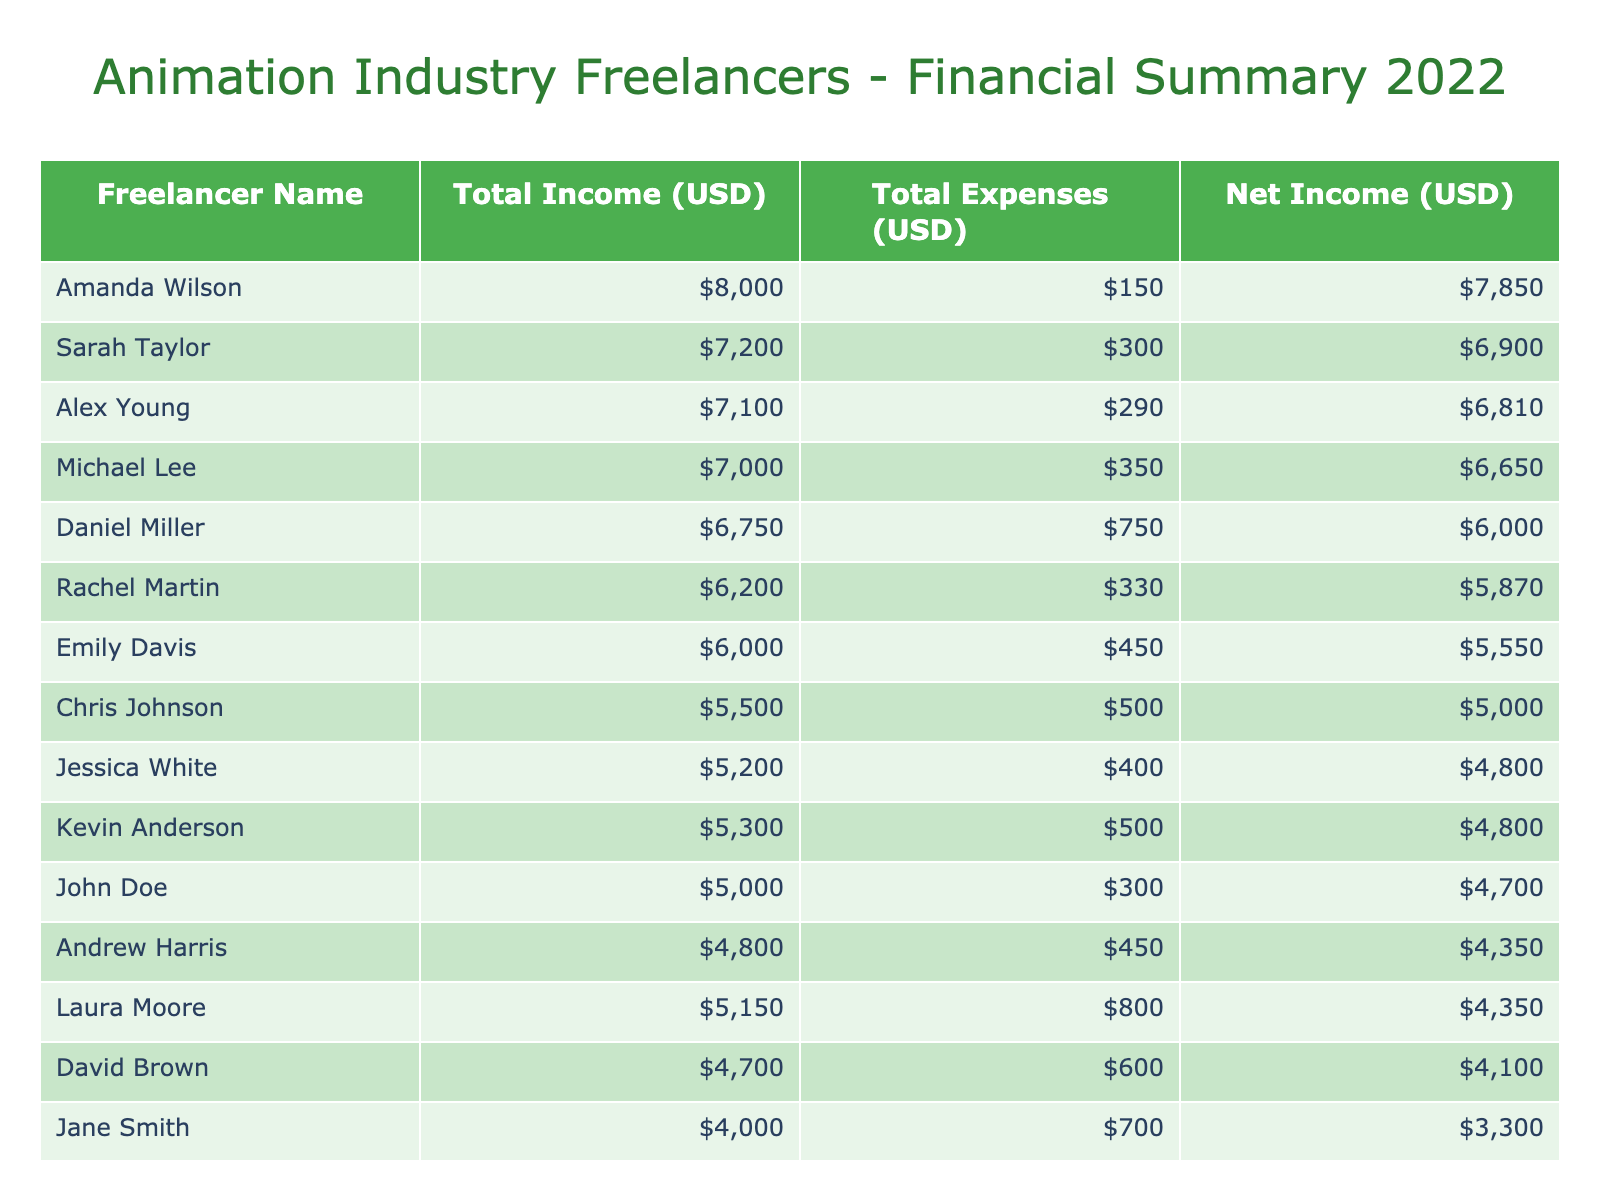What is the total income earned by Amanda Wilson? In the table, we look for the entry with "Amanda Wilson" under the Freelancer Name column. Her income is listed as 8000 USD.
Answer: 8000 USD Who has the highest total expenses among the freelancers? To find this, we compare the "Expense Amount (USD)" for each freelancer in the table. Amanda Wilson has expenses of 150 USD, which is the lowest. The highest expenses are observed for Laura Moore at 800 USD.
Answer: Laura Moore What is the net income for Sarah Taylor? For Sarah Taylor, her total income is 7200 USD, and her total expenses are 300 USD. Net income is calculated by subtracting expenses from income, which is 7200 - 300 = 6900 USD.
Answer: 6900 USD What is the average total income of all freelancers? First, we sum the incomes of each freelancer: 5000 + 4000 + 6000 + 7000 + 5500 + 4700 + 8000 + 5200 + 6750 + 7200 + 4800 + 5150 + 5300 + 6200 + 7100 = 102,200. There are 15 freelancers, so the average income is 102,200 / 15 = 6,813.33 USD.
Answer: 6,813.33 USD Is the total income of Chris Johnson higher than Jane Smith? Chris Johnson's total income is 5500 USD, while Jane Smith's total income is 4000 USD. Since 5500 is greater than 4000, the answer is yes.
Answer: Yes What is the difference in net income between John Doe and Daniel Miller? John Doe's net income is 5000 - 300 = 4700 USD, and Daniel Miller's net income is 6750 - 750 = 6000 USD. The difference in net income is 6000 - 4700 = 1300 USD.
Answer: 1300 USD Which freelancer has a net income less than 5000 USD? We calculate the net income for each freelancer. After calculation, we find that John Doe (4700 USD) and David Brown (4100 USD) both have net incomes below 5000 USD.
Answer: John Doe, David Brown What is the total income of freelancers whose projects are with Disney? The freelancers with projects at Disney are Emily Davis (6000 USD) and Alex Young (7100 USD). We sum their incomes: 6000 + 7100 = 13100 USD.
Answer: 13100 USD 